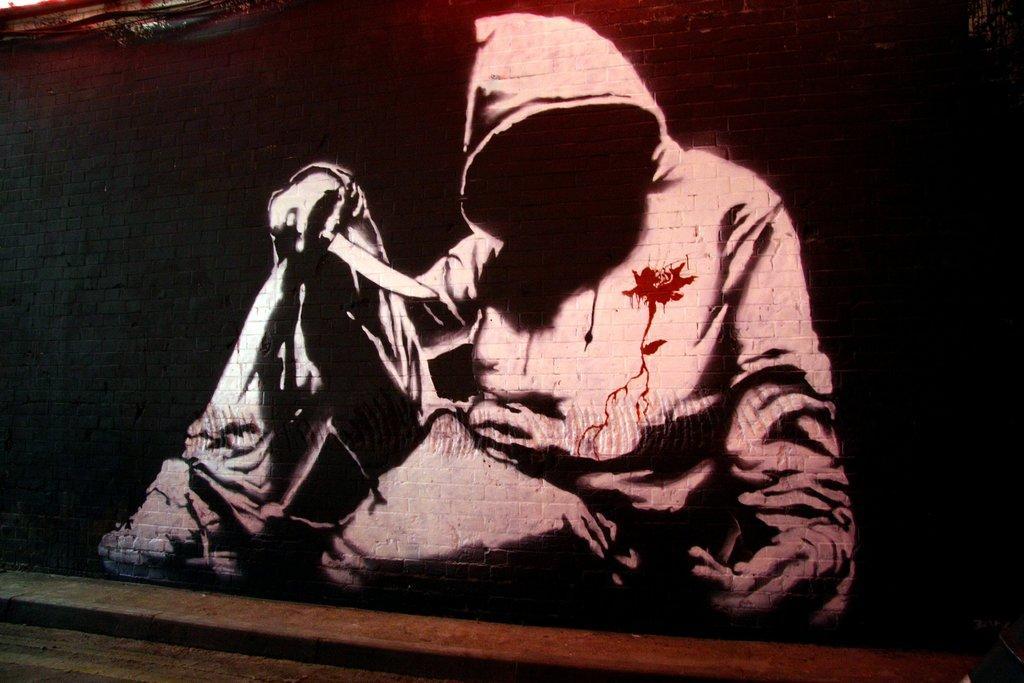In one or two sentences, can you explain what this image depicts? In this picture I can see a painting of a person sitting and holding a knife, on the wall. 